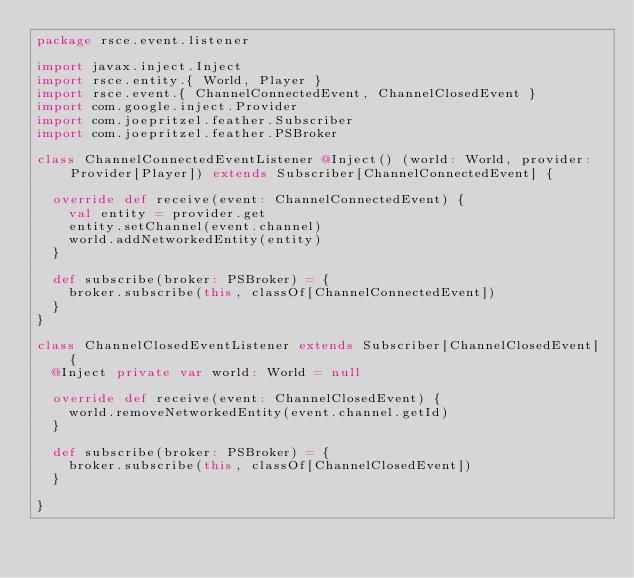<code> <loc_0><loc_0><loc_500><loc_500><_Scala_>package rsce.event.listener

import javax.inject.Inject
import rsce.entity.{ World, Player }
import rsce.event.{ ChannelConnectedEvent, ChannelClosedEvent }
import com.google.inject.Provider
import com.joepritzel.feather.Subscriber
import com.joepritzel.feather.PSBroker

class ChannelConnectedEventListener @Inject() (world: World, provider: Provider[Player]) extends Subscriber[ChannelConnectedEvent] {

  override def receive(event: ChannelConnectedEvent) {
    val entity = provider.get
    entity.setChannel(event.channel)
    world.addNetworkedEntity(entity)
  }

  def subscribe(broker: PSBroker) = {
    broker.subscribe(this, classOf[ChannelConnectedEvent])
  }
}

class ChannelClosedEventListener extends Subscriber[ChannelClosedEvent] {
  @Inject private var world: World = null

  override def receive(event: ChannelClosedEvent) {
    world.removeNetworkedEntity(event.channel.getId)
  }

  def subscribe(broker: PSBroker) = {
    broker.subscribe(this, classOf[ChannelClosedEvent])
  }

}</code> 